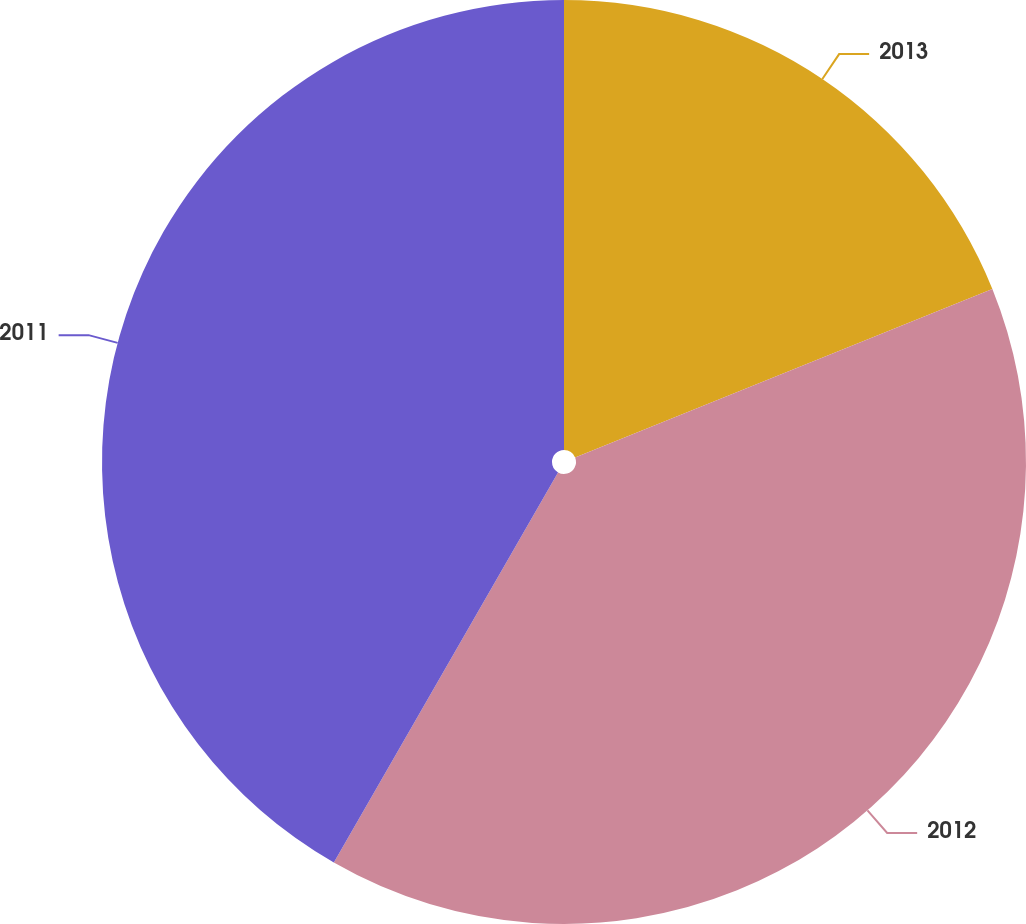Convert chart to OTSL. <chart><loc_0><loc_0><loc_500><loc_500><pie_chart><fcel>2013<fcel>2012<fcel>2011<nl><fcel>18.89%<fcel>39.41%<fcel>41.7%<nl></chart> 